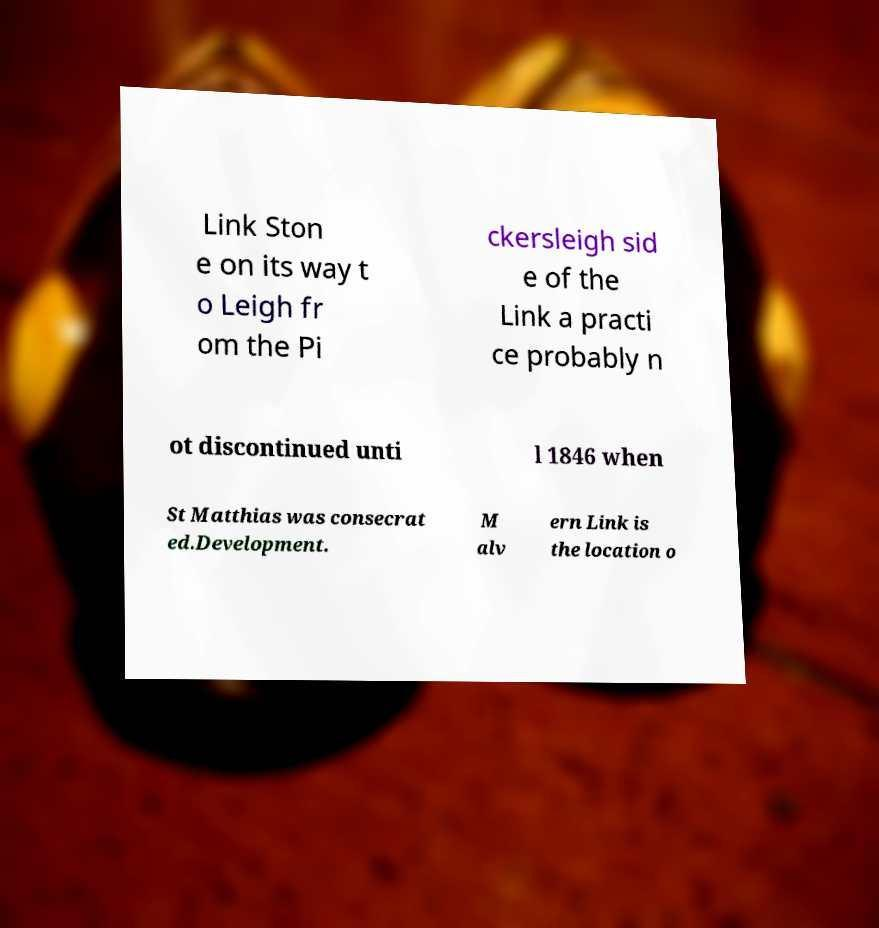I need the written content from this picture converted into text. Can you do that? Link Ston e on its way t o Leigh fr om the Pi ckersleigh sid e of the Link a practi ce probably n ot discontinued unti l 1846 when St Matthias was consecrat ed.Development. M alv ern Link is the location o 